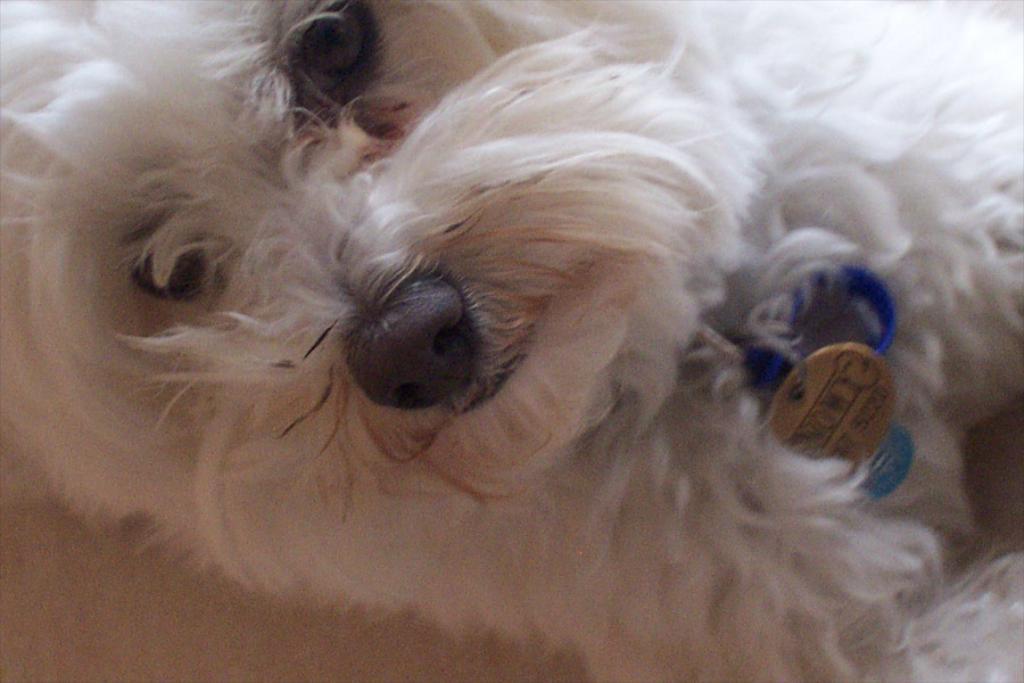Please provide a concise description of this image. In this image we can see a dog. 